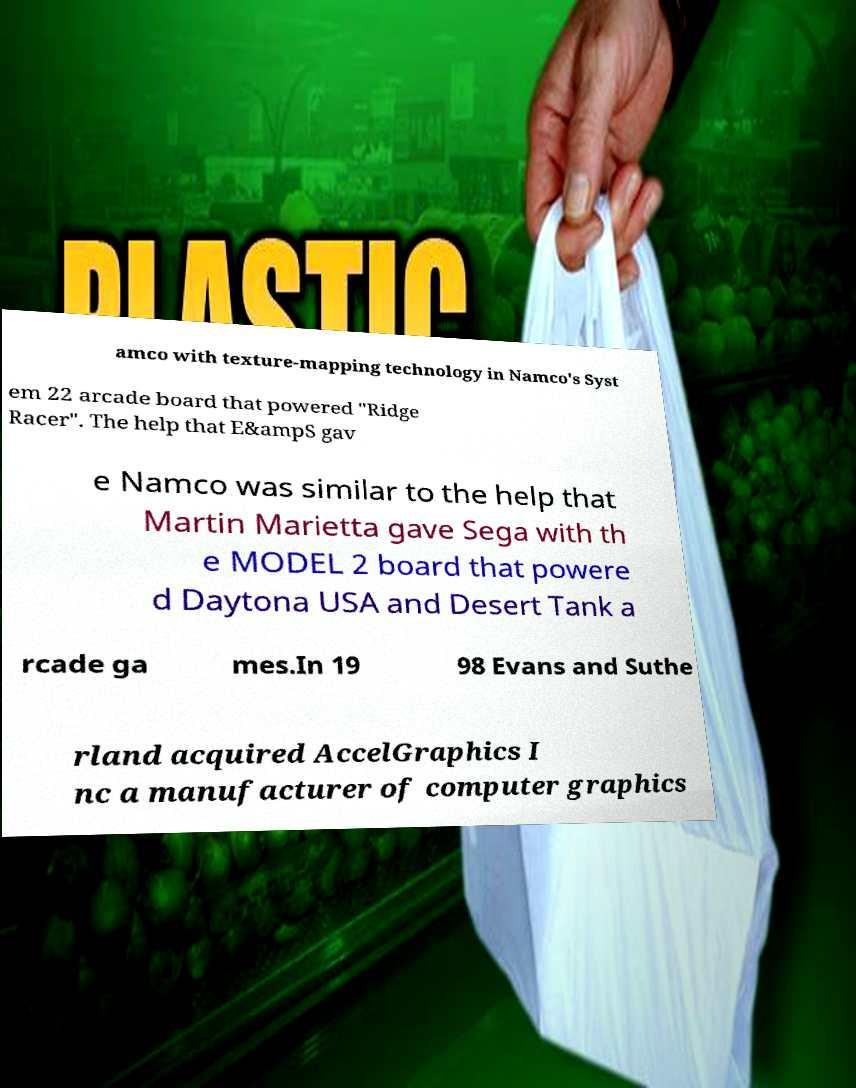Please identify and transcribe the text found in this image. amco with texture-mapping technology in Namco's Syst em 22 arcade board that powered "Ridge Racer". The help that E&ampS gav e Namco was similar to the help that Martin Marietta gave Sega with th e MODEL 2 board that powere d Daytona USA and Desert Tank a rcade ga mes.In 19 98 Evans and Suthe rland acquired AccelGraphics I nc a manufacturer of computer graphics 